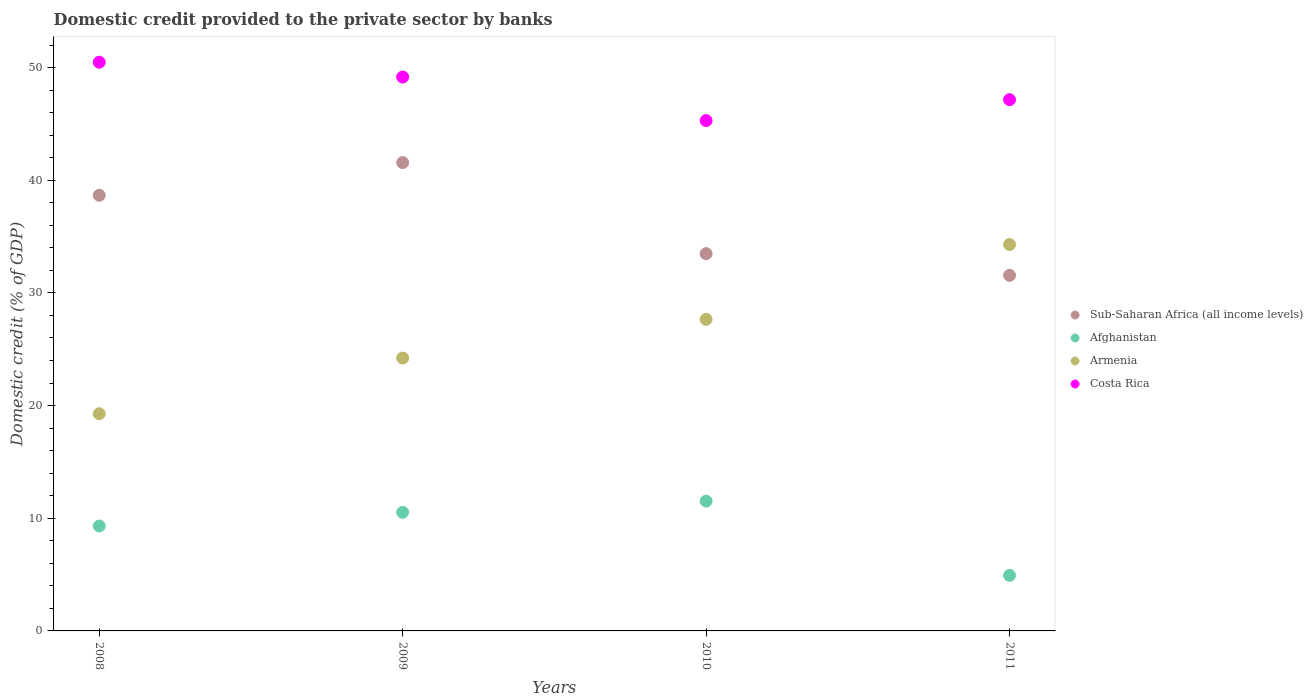What is the domestic credit provided to the private sector by banks in Afghanistan in 2008?
Make the answer very short. 9.31. Across all years, what is the maximum domestic credit provided to the private sector by banks in Afghanistan?
Provide a succinct answer. 11.52. Across all years, what is the minimum domestic credit provided to the private sector by banks in Afghanistan?
Your answer should be compact. 4.93. In which year was the domestic credit provided to the private sector by banks in Armenia minimum?
Your answer should be very brief. 2008. What is the total domestic credit provided to the private sector by banks in Sub-Saharan Africa (all income levels) in the graph?
Ensure brevity in your answer.  145.27. What is the difference between the domestic credit provided to the private sector by banks in Armenia in 2008 and that in 2011?
Give a very brief answer. -15.02. What is the difference between the domestic credit provided to the private sector by banks in Afghanistan in 2009 and the domestic credit provided to the private sector by banks in Costa Rica in 2008?
Provide a short and direct response. -39.95. What is the average domestic credit provided to the private sector by banks in Costa Rica per year?
Your response must be concise. 48.02. In the year 2009, what is the difference between the domestic credit provided to the private sector by banks in Costa Rica and domestic credit provided to the private sector by banks in Sub-Saharan Africa (all income levels)?
Ensure brevity in your answer.  7.59. In how many years, is the domestic credit provided to the private sector by banks in Sub-Saharan Africa (all income levels) greater than 18 %?
Give a very brief answer. 4. What is the ratio of the domestic credit provided to the private sector by banks in Costa Rica in 2009 to that in 2010?
Your answer should be very brief. 1.09. Is the domestic credit provided to the private sector by banks in Armenia in 2008 less than that in 2009?
Keep it short and to the point. Yes. Is the difference between the domestic credit provided to the private sector by banks in Costa Rica in 2008 and 2009 greater than the difference between the domestic credit provided to the private sector by banks in Sub-Saharan Africa (all income levels) in 2008 and 2009?
Offer a very short reply. Yes. What is the difference between the highest and the second highest domestic credit provided to the private sector by banks in Sub-Saharan Africa (all income levels)?
Provide a succinct answer. 2.9. What is the difference between the highest and the lowest domestic credit provided to the private sector by banks in Sub-Saharan Africa (all income levels)?
Provide a short and direct response. 10.01. In how many years, is the domestic credit provided to the private sector by banks in Costa Rica greater than the average domestic credit provided to the private sector by banks in Costa Rica taken over all years?
Make the answer very short. 2. Is the sum of the domestic credit provided to the private sector by banks in Afghanistan in 2009 and 2011 greater than the maximum domestic credit provided to the private sector by banks in Sub-Saharan Africa (all income levels) across all years?
Your answer should be very brief. No. Is it the case that in every year, the sum of the domestic credit provided to the private sector by banks in Sub-Saharan Africa (all income levels) and domestic credit provided to the private sector by banks in Afghanistan  is greater than the domestic credit provided to the private sector by banks in Costa Rica?
Make the answer very short. No. Is the domestic credit provided to the private sector by banks in Sub-Saharan Africa (all income levels) strictly greater than the domestic credit provided to the private sector by banks in Afghanistan over the years?
Provide a succinct answer. Yes. How many dotlines are there?
Your answer should be compact. 4. What is the difference between two consecutive major ticks on the Y-axis?
Provide a succinct answer. 10. Are the values on the major ticks of Y-axis written in scientific E-notation?
Offer a terse response. No. Does the graph contain any zero values?
Make the answer very short. No. Where does the legend appear in the graph?
Offer a very short reply. Center right. How many legend labels are there?
Offer a very short reply. 4. What is the title of the graph?
Your answer should be compact. Domestic credit provided to the private sector by banks. What is the label or title of the X-axis?
Offer a terse response. Years. What is the label or title of the Y-axis?
Offer a very short reply. Domestic credit (% of GDP). What is the Domestic credit (% of GDP) in Sub-Saharan Africa (all income levels) in 2008?
Ensure brevity in your answer.  38.66. What is the Domestic credit (% of GDP) in Afghanistan in 2008?
Ensure brevity in your answer.  9.31. What is the Domestic credit (% of GDP) in Armenia in 2008?
Give a very brief answer. 19.27. What is the Domestic credit (% of GDP) in Costa Rica in 2008?
Make the answer very short. 50.47. What is the Domestic credit (% of GDP) in Sub-Saharan Africa (all income levels) in 2009?
Ensure brevity in your answer.  41.57. What is the Domestic credit (% of GDP) in Afghanistan in 2009?
Offer a terse response. 10.53. What is the Domestic credit (% of GDP) of Armenia in 2009?
Offer a terse response. 24.22. What is the Domestic credit (% of GDP) in Costa Rica in 2009?
Your answer should be very brief. 49.16. What is the Domestic credit (% of GDP) of Sub-Saharan Africa (all income levels) in 2010?
Offer a terse response. 33.48. What is the Domestic credit (% of GDP) of Afghanistan in 2010?
Provide a short and direct response. 11.52. What is the Domestic credit (% of GDP) in Armenia in 2010?
Your response must be concise. 27.66. What is the Domestic credit (% of GDP) in Costa Rica in 2010?
Provide a short and direct response. 45.29. What is the Domestic credit (% of GDP) of Sub-Saharan Africa (all income levels) in 2011?
Provide a short and direct response. 31.56. What is the Domestic credit (% of GDP) in Afghanistan in 2011?
Provide a short and direct response. 4.93. What is the Domestic credit (% of GDP) in Armenia in 2011?
Your response must be concise. 34.29. What is the Domestic credit (% of GDP) in Costa Rica in 2011?
Keep it short and to the point. 47.15. Across all years, what is the maximum Domestic credit (% of GDP) of Sub-Saharan Africa (all income levels)?
Give a very brief answer. 41.57. Across all years, what is the maximum Domestic credit (% of GDP) in Afghanistan?
Your answer should be compact. 11.52. Across all years, what is the maximum Domestic credit (% of GDP) of Armenia?
Keep it short and to the point. 34.29. Across all years, what is the maximum Domestic credit (% of GDP) in Costa Rica?
Offer a terse response. 50.47. Across all years, what is the minimum Domestic credit (% of GDP) in Sub-Saharan Africa (all income levels)?
Keep it short and to the point. 31.56. Across all years, what is the minimum Domestic credit (% of GDP) of Afghanistan?
Your answer should be very brief. 4.93. Across all years, what is the minimum Domestic credit (% of GDP) of Armenia?
Your answer should be compact. 19.27. Across all years, what is the minimum Domestic credit (% of GDP) in Costa Rica?
Give a very brief answer. 45.29. What is the total Domestic credit (% of GDP) in Sub-Saharan Africa (all income levels) in the graph?
Offer a very short reply. 145.27. What is the total Domestic credit (% of GDP) of Afghanistan in the graph?
Provide a short and direct response. 36.28. What is the total Domestic credit (% of GDP) of Armenia in the graph?
Provide a short and direct response. 105.44. What is the total Domestic credit (% of GDP) in Costa Rica in the graph?
Your answer should be very brief. 192.07. What is the difference between the Domestic credit (% of GDP) in Sub-Saharan Africa (all income levels) in 2008 and that in 2009?
Offer a very short reply. -2.9. What is the difference between the Domestic credit (% of GDP) in Afghanistan in 2008 and that in 2009?
Keep it short and to the point. -1.21. What is the difference between the Domestic credit (% of GDP) in Armenia in 2008 and that in 2009?
Your answer should be very brief. -4.94. What is the difference between the Domestic credit (% of GDP) in Costa Rica in 2008 and that in 2009?
Your answer should be very brief. 1.31. What is the difference between the Domestic credit (% of GDP) of Sub-Saharan Africa (all income levels) in 2008 and that in 2010?
Ensure brevity in your answer.  5.18. What is the difference between the Domestic credit (% of GDP) in Afghanistan in 2008 and that in 2010?
Offer a terse response. -2.2. What is the difference between the Domestic credit (% of GDP) in Armenia in 2008 and that in 2010?
Your response must be concise. -8.38. What is the difference between the Domestic credit (% of GDP) of Costa Rica in 2008 and that in 2010?
Offer a terse response. 5.18. What is the difference between the Domestic credit (% of GDP) of Sub-Saharan Africa (all income levels) in 2008 and that in 2011?
Ensure brevity in your answer.  7.11. What is the difference between the Domestic credit (% of GDP) of Afghanistan in 2008 and that in 2011?
Your answer should be compact. 4.38. What is the difference between the Domestic credit (% of GDP) of Armenia in 2008 and that in 2011?
Offer a very short reply. -15.02. What is the difference between the Domestic credit (% of GDP) of Costa Rica in 2008 and that in 2011?
Make the answer very short. 3.32. What is the difference between the Domestic credit (% of GDP) in Sub-Saharan Africa (all income levels) in 2009 and that in 2010?
Offer a terse response. 8.09. What is the difference between the Domestic credit (% of GDP) of Afghanistan in 2009 and that in 2010?
Provide a succinct answer. -0.99. What is the difference between the Domestic credit (% of GDP) of Armenia in 2009 and that in 2010?
Keep it short and to the point. -3.44. What is the difference between the Domestic credit (% of GDP) of Costa Rica in 2009 and that in 2010?
Ensure brevity in your answer.  3.87. What is the difference between the Domestic credit (% of GDP) in Sub-Saharan Africa (all income levels) in 2009 and that in 2011?
Offer a very short reply. 10.01. What is the difference between the Domestic credit (% of GDP) of Afghanistan in 2009 and that in 2011?
Make the answer very short. 5.6. What is the difference between the Domestic credit (% of GDP) in Armenia in 2009 and that in 2011?
Give a very brief answer. -10.08. What is the difference between the Domestic credit (% of GDP) of Costa Rica in 2009 and that in 2011?
Provide a succinct answer. 2.01. What is the difference between the Domestic credit (% of GDP) of Sub-Saharan Africa (all income levels) in 2010 and that in 2011?
Ensure brevity in your answer.  1.92. What is the difference between the Domestic credit (% of GDP) in Afghanistan in 2010 and that in 2011?
Provide a short and direct response. 6.59. What is the difference between the Domestic credit (% of GDP) of Armenia in 2010 and that in 2011?
Provide a short and direct response. -6.64. What is the difference between the Domestic credit (% of GDP) of Costa Rica in 2010 and that in 2011?
Make the answer very short. -1.86. What is the difference between the Domestic credit (% of GDP) of Sub-Saharan Africa (all income levels) in 2008 and the Domestic credit (% of GDP) of Afghanistan in 2009?
Offer a terse response. 28.14. What is the difference between the Domestic credit (% of GDP) in Sub-Saharan Africa (all income levels) in 2008 and the Domestic credit (% of GDP) in Armenia in 2009?
Offer a very short reply. 14.45. What is the difference between the Domestic credit (% of GDP) in Sub-Saharan Africa (all income levels) in 2008 and the Domestic credit (% of GDP) in Costa Rica in 2009?
Your answer should be very brief. -10.49. What is the difference between the Domestic credit (% of GDP) in Afghanistan in 2008 and the Domestic credit (% of GDP) in Armenia in 2009?
Offer a terse response. -14.9. What is the difference between the Domestic credit (% of GDP) in Afghanistan in 2008 and the Domestic credit (% of GDP) in Costa Rica in 2009?
Keep it short and to the point. -39.85. What is the difference between the Domestic credit (% of GDP) in Armenia in 2008 and the Domestic credit (% of GDP) in Costa Rica in 2009?
Keep it short and to the point. -29.88. What is the difference between the Domestic credit (% of GDP) of Sub-Saharan Africa (all income levels) in 2008 and the Domestic credit (% of GDP) of Afghanistan in 2010?
Offer a very short reply. 27.15. What is the difference between the Domestic credit (% of GDP) of Sub-Saharan Africa (all income levels) in 2008 and the Domestic credit (% of GDP) of Armenia in 2010?
Your response must be concise. 11.01. What is the difference between the Domestic credit (% of GDP) of Sub-Saharan Africa (all income levels) in 2008 and the Domestic credit (% of GDP) of Costa Rica in 2010?
Your response must be concise. -6.63. What is the difference between the Domestic credit (% of GDP) in Afghanistan in 2008 and the Domestic credit (% of GDP) in Armenia in 2010?
Your answer should be very brief. -18.34. What is the difference between the Domestic credit (% of GDP) in Afghanistan in 2008 and the Domestic credit (% of GDP) in Costa Rica in 2010?
Offer a very short reply. -35.98. What is the difference between the Domestic credit (% of GDP) of Armenia in 2008 and the Domestic credit (% of GDP) of Costa Rica in 2010?
Offer a terse response. -26.02. What is the difference between the Domestic credit (% of GDP) in Sub-Saharan Africa (all income levels) in 2008 and the Domestic credit (% of GDP) in Afghanistan in 2011?
Offer a very short reply. 33.74. What is the difference between the Domestic credit (% of GDP) of Sub-Saharan Africa (all income levels) in 2008 and the Domestic credit (% of GDP) of Armenia in 2011?
Make the answer very short. 4.37. What is the difference between the Domestic credit (% of GDP) in Sub-Saharan Africa (all income levels) in 2008 and the Domestic credit (% of GDP) in Costa Rica in 2011?
Your answer should be compact. -8.49. What is the difference between the Domestic credit (% of GDP) in Afghanistan in 2008 and the Domestic credit (% of GDP) in Armenia in 2011?
Your answer should be very brief. -24.98. What is the difference between the Domestic credit (% of GDP) in Afghanistan in 2008 and the Domestic credit (% of GDP) in Costa Rica in 2011?
Your answer should be very brief. -37.84. What is the difference between the Domestic credit (% of GDP) in Armenia in 2008 and the Domestic credit (% of GDP) in Costa Rica in 2011?
Make the answer very short. -27.88. What is the difference between the Domestic credit (% of GDP) of Sub-Saharan Africa (all income levels) in 2009 and the Domestic credit (% of GDP) of Afghanistan in 2010?
Offer a terse response. 30.05. What is the difference between the Domestic credit (% of GDP) in Sub-Saharan Africa (all income levels) in 2009 and the Domestic credit (% of GDP) in Armenia in 2010?
Ensure brevity in your answer.  13.91. What is the difference between the Domestic credit (% of GDP) of Sub-Saharan Africa (all income levels) in 2009 and the Domestic credit (% of GDP) of Costa Rica in 2010?
Give a very brief answer. -3.72. What is the difference between the Domestic credit (% of GDP) in Afghanistan in 2009 and the Domestic credit (% of GDP) in Armenia in 2010?
Offer a very short reply. -17.13. What is the difference between the Domestic credit (% of GDP) in Afghanistan in 2009 and the Domestic credit (% of GDP) in Costa Rica in 2010?
Your response must be concise. -34.77. What is the difference between the Domestic credit (% of GDP) in Armenia in 2009 and the Domestic credit (% of GDP) in Costa Rica in 2010?
Keep it short and to the point. -21.07. What is the difference between the Domestic credit (% of GDP) of Sub-Saharan Africa (all income levels) in 2009 and the Domestic credit (% of GDP) of Afghanistan in 2011?
Offer a very short reply. 36.64. What is the difference between the Domestic credit (% of GDP) of Sub-Saharan Africa (all income levels) in 2009 and the Domestic credit (% of GDP) of Armenia in 2011?
Your answer should be very brief. 7.28. What is the difference between the Domestic credit (% of GDP) of Sub-Saharan Africa (all income levels) in 2009 and the Domestic credit (% of GDP) of Costa Rica in 2011?
Give a very brief answer. -5.58. What is the difference between the Domestic credit (% of GDP) of Afghanistan in 2009 and the Domestic credit (% of GDP) of Armenia in 2011?
Provide a short and direct response. -23.77. What is the difference between the Domestic credit (% of GDP) in Afghanistan in 2009 and the Domestic credit (% of GDP) in Costa Rica in 2011?
Offer a very short reply. -36.62. What is the difference between the Domestic credit (% of GDP) of Armenia in 2009 and the Domestic credit (% of GDP) of Costa Rica in 2011?
Offer a terse response. -22.93. What is the difference between the Domestic credit (% of GDP) of Sub-Saharan Africa (all income levels) in 2010 and the Domestic credit (% of GDP) of Afghanistan in 2011?
Ensure brevity in your answer.  28.55. What is the difference between the Domestic credit (% of GDP) in Sub-Saharan Africa (all income levels) in 2010 and the Domestic credit (% of GDP) in Armenia in 2011?
Offer a very short reply. -0.81. What is the difference between the Domestic credit (% of GDP) of Sub-Saharan Africa (all income levels) in 2010 and the Domestic credit (% of GDP) of Costa Rica in 2011?
Ensure brevity in your answer.  -13.67. What is the difference between the Domestic credit (% of GDP) of Afghanistan in 2010 and the Domestic credit (% of GDP) of Armenia in 2011?
Your answer should be very brief. -22.78. What is the difference between the Domestic credit (% of GDP) in Afghanistan in 2010 and the Domestic credit (% of GDP) in Costa Rica in 2011?
Make the answer very short. -35.63. What is the difference between the Domestic credit (% of GDP) in Armenia in 2010 and the Domestic credit (% of GDP) in Costa Rica in 2011?
Provide a short and direct response. -19.49. What is the average Domestic credit (% of GDP) in Sub-Saharan Africa (all income levels) per year?
Your response must be concise. 36.32. What is the average Domestic credit (% of GDP) in Afghanistan per year?
Offer a very short reply. 9.07. What is the average Domestic credit (% of GDP) in Armenia per year?
Your response must be concise. 26.36. What is the average Domestic credit (% of GDP) in Costa Rica per year?
Your answer should be very brief. 48.02. In the year 2008, what is the difference between the Domestic credit (% of GDP) of Sub-Saharan Africa (all income levels) and Domestic credit (% of GDP) of Afghanistan?
Ensure brevity in your answer.  29.35. In the year 2008, what is the difference between the Domestic credit (% of GDP) of Sub-Saharan Africa (all income levels) and Domestic credit (% of GDP) of Armenia?
Ensure brevity in your answer.  19.39. In the year 2008, what is the difference between the Domestic credit (% of GDP) of Sub-Saharan Africa (all income levels) and Domestic credit (% of GDP) of Costa Rica?
Offer a very short reply. -11.81. In the year 2008, what is the difference between the Domestic credit (% of GDP) in Afghanistan and Domestic credit (% of GDP) in Armenia?
Ensure brevity in your answer.  -9.96. In the year 2008, what is the difference between the Domestic credit (% of GDP) of Afghanistan and Domestic credit (% of GDP) of Costa Rica?
Ensure brevity in your answer.  -41.16. In the year 2008, what is the difference between the Domestic credit (% of GDP) in Armenia and Domestic credit (% of GDP) in Costa Rica?
Your answer should be compact. -31.2. In the year 2009, what is the difference between the Domestic credit (% of GDP) of Sub-Saharan Africa (all income levels) and Domestic credit (% of GDP) of Afghanistan?
Provide a short and direct response. 31.04. In the year 2009, what is the difference between the Domestic credit (% of GDP) of Sub-Saharan Africa (all income levels) and Domestic credit (% of GDP) of Armenia?
Your answer should be compact. 17.35. In the year 2009, what is the difference between the Domestic credit (% of GDP) in Sub-Saharan Africa (all income levels) and Domestic credit (% of GDP) in Costa Rica?
Make the answer very short. -7.59. In the year 2009, what is the difference between the Domestic credit (% of GDP) of Afghanistan and Domestic credit (% of GDP) of Armenia?
Give a very brief answer. -13.69. In the year 2009, what is the difference between the Domestic credit (% of GDP) of Afghanistan and Domestic credit (% of GDP) of Costa Rica?
Your response must be concise. -38.63. In the year 2009, what is the difference between the Domestic credit (% of GDP) of Armenia and Domestic credit (% of GDP) of Costa Rica?
Provide a short and direct response. -24.94. In the year 2010, what is the difference between the Domestic credit (% of GDP) of Sub-Saharan Africa (all income levels) and Domestic credit (% of GDP) of Afghanistan?
Your response must be concise. 21.97. In the year 2010, what is the difference between the Domestic credit (% of GDP) in Sub-Saharan Africa (all income levels) and Domestic credit (% of GDP) in Armenia?
Your answer should be compact. 5.83. In the year 2010, what is the difference between the Domestic credit (% of GDP) in Sub-Saharan Africa (all income levels) and Domestic credit (% of GDP) in Costa Rica?
Offer a very short reply. -11.81. In the year 2010, what is the difference between the Domestic credit (% of GDP) of Afghanistan and Domestic credit (% of GDP) of Armenia?
Your answer should be compact. -16.14. In the year 2010, what is the difference between the Domestic credit (% of GDP) in Afghanistan and Domestic credit (% of GDP) in Costa Rica?
Offer a terse response. -33.77. In the year 2010, what is the difference between the Domestic credit (% of GDP) of Armenia and Domestic credit (% of GDP) of Costa Rica?
Your answer should be compact. -17.64. In the year 2011, what is the difference between the Domestic credit (% of GDP) of Sub-Saharan Africa (all income levels) and Domestic credit (% of GDP) of Afghanistan?
Provide a succinct answer. 26.63. In the year 2011, what is the difference between the Domestic credit (% of GDP) in Sub-Saharan Africa (all income levels) and Domestic credit (% of GDP) in Armenia?
Offer a terse response. -2.73. In the year 2011, what is the difference between the Domestic credit (% of GDP) in Sub-Saharan Africa (all income levels) and Domestic credit (% of GDP) in Costa Rica?
Offer a terse response. -15.59. In the year 2011, what is the difference between the Domestic credit (% of GDP) of Afghanistan and Domestic credit (% of GDP) of Armenia?
Offer a very short reply. -29.36. In the year 2011, what is the difference between the Domestic credit (% of GDP) in Afghanistan and Domestic credit (% of GDP) in Costa Rica?
Your answer should be very brief. -42.22. In the year 2011, what is the difference between the Domestic credit (% of GDP) of Armenia and Domestic credit (% of GDP) of Costa Rica?
Provide a succinct answer. -12.86. What is the ratio of the Domestic credit (% of GDP) of Sub-Saharan Africa (all income levels) in 2008 to that in 2009?
Keep it short and to the point. 0.93. What is the ratio of the Domestic credit (% of GDP) of Afghanistan in 2008 to that in 2009?
Give a very brief answer. 0.88. What is the ratio of the Domestic credit (% of GDP) in Armenia in 2008 to that in 2009?
Offer a very short reply. 0.8. What is the ratio of the Domestic credit (% of GDP) of Costa Rica in 2008 to that in 2009?
Give a very brief answer. 1.03. What is the ratio of the Domestic credit (% of GDP) in Sub-Saharan Africa (all income levels) in 2008 to that in 2010?
Keep it short and to the point. 1.15. What is the ratio of the Domestic credit (% of GDP) in Afghanistan in 2008 to that in 2010?
Keep it short and to the point. 0.81. What is the ratio of the Domestic credit (% of GDP) in Armenia in 2008 to that in 2010?
Offer a very short reply. 0.7. What is the ratio of the Domestic credit (% of GDP) of Costa Rica in 2008 to that in 2010?
Give a very brief answer. 1.11. What is the ratio of the Domestic credit (% of GDP) of Sub-Saharan Africa (all income levels) in 2008 to that in 2011?
Ensure brevity in your answer.  1.23. What is the ratio of the Domestic credit (% of GDP) in Afghanistan in 2008 to that in 2011?
Your response must be concise. 1.89. What is the ratio of the Domestic credit (% of GDP) of Armenia in 2008 to that in 2011?
Make the answer very short. 0.56. What is the ratio of the Domestic credit (% of GDP) of Costa Rica in 2008 to that in 2011?
Offer a terse response. 1.07. What is the ratio of the Domestic credit (% of GDP) in Sub-Saharan Africa (all income levels) in 2009 to that in 2010?
Ensure brevity in your answer.  1.24. What is the ratio of the Domestic credit (% of GDP) in Afghanistan in 2009 to that in 2010?
Your answer should be compact. 0.91. What is the ratio of the Domestic credit (% of GDP) of Armenia in 2009 to that in 2010?
Give a very brief answer. 0.88. What is the ratio of the Domestic credit (% of GDP) in Costa Rica in 2009 to that in 2010?
Make the answer very short. 1.09. What is the ratio of the Domestic credit (% of GDP) in Sub-Saharan Africa (all income levels) in 2009 to that in 2011?
Give a very brief answer. 1.32. What is the ratio of the Domestic credit (% of GDP) of Afghanistan in 2009 to that in 2011?
Make the answer very short. 2.14. What is the ratio of the Domestic credit (% of GDP) of Armenia in 2009 to that in 2011?
Provide a succinct answer. 0.71. What is the ratio of the Domestic credit (% of GDP) in Costa Rica in 2009 to that in 2011?
Provide a succinct answer. 1.04. What is the ratio of the Domestic credit (% of GDP) in Sub-Saharan Africa (all income levels) in 2010 to that in 2011?
Provide a short and direct response. 1.06. What is the ratio of the Domestic credit (% of GDP) in Afghanistan in 2010 to that in 2011?
Your response must be concise. 2.34. What is the ratio of the Domestic credit (% of GDP) in Armenia in 2010 to that in 2011?
Provide a succinct answer. 0.81. What is the ratio of the Domestic credit (% of GDP) of Costa Rica in 2010 to that in 2011?
Provide a short and direct response. 0.96. What is the difference between the highest and the second highest Domestic credit (% of GDP) of Sub-Saharan Africa (all income levels)?
Ensure brevity in your answer.  2.9. What is the difference between the highest and the second highest Domestic credit (% of GDP) of Afghanistan?
Ensure brevity in your answer.  0.99. What is the difference between the highest and the second highest Domestic credit (% of GDP) in Armenia?
Provide a short and direct response. 6.64. What is the difference between the highest and the second highest Domestic credit (% of GDP) in Costa Rica?
Provide a succinct answer. 1.31. What is the difference between the highest and the lowest Domestic credit (% of GDP) in Sub-Saharan Africa (all income levels)?
Your answer should be compact. 10.01. What is the difference between the highest and the lowest Domestic credit (% of GDP) in Afghanistan?
Your answer should be very brief. 6.59. What is the difference between the highest and the lowest Domestic credit (% of GDP) in Armenia?
Provide a short and direct response. 15.02. What is the difference between the highest and the lowest Domestic credit (% of GDP) in Costa Rica?
Offer a very short reply. 5.18. 